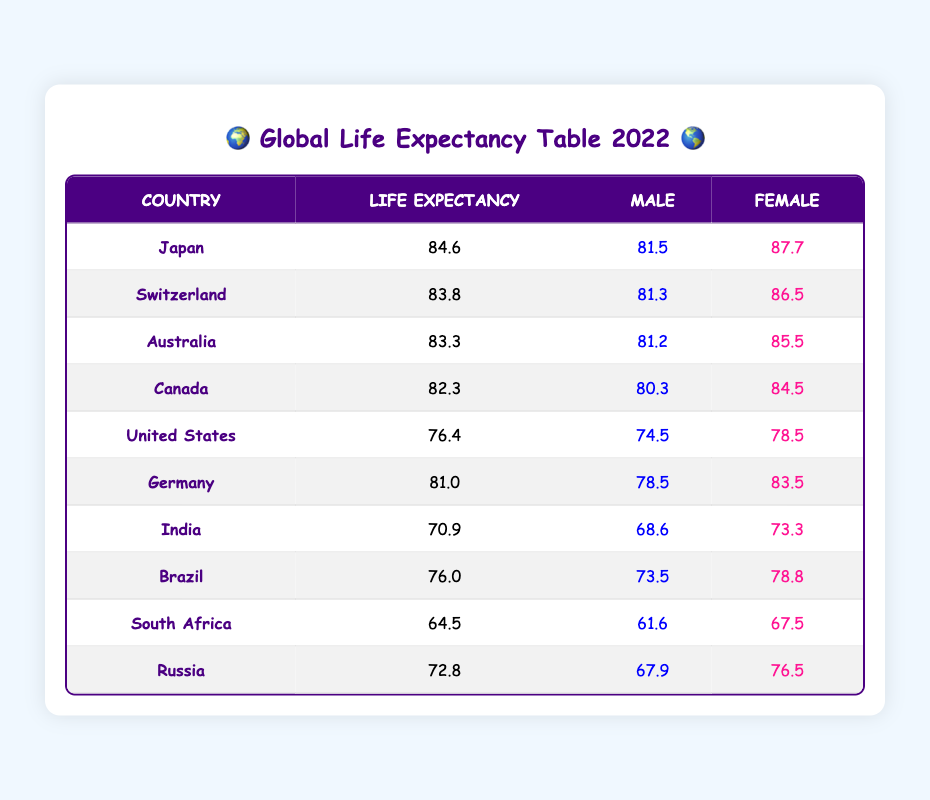What is the life expectancy of Japan? The life expectancy of Japan is directly listed in the table under the life expectancy column for Japan, which shows 84.6 years.
Answer: 84.6 Which country has the highest life expectancy? Looking at the life expectancy column, Japan has the highest value of 84.6, compared to other countries listed.
Answer: Japan What is the life expectancy difference between males and females in Switzerland? For Switzerland, the life expectancy for males is 81.3 and for females is 86.5. The difference is calculated as 86.5 - 81.3 = 5.2 years.
Answer: 5.2 Is the life expectancy of females in India higher than males? The life expectancy for females in India is 73.3 and for males is 68.6. Since 73.3 is greater than 68.6, the answer is yes.
Answer: Yes What is the average life expectancy of the listed countries? The life expectancies of the countries are summed: 84.6 + 83.8 + 83.3 + 82.3 + 76.4 + 81.0 + 70.9 + 76.0 + 64.5 + 72.8 =  743.6. Then, divide by 10 (the number of countries) gives an average of 74.36 years.
Answer: 74.36 How many countries have a life expectancy above 80 years? By inspecting each country in the table, Japan (84.6), Switzerland (83.8), Australia (83.3), and Canada (82.3) have life expectancies above 80 years. This results in a total of 4 countries.
Answer: 4 What is the combined life expectancy of males in Germany and Canada? The life expectancies for males are 78.5 (Germany) and 80.3 (Canada). Their total is 78.5 + 80.3 = 158.8 years.
Answer: 158.8 Is Brazil's life expectancy lower than that of the United States? Brazil has a life expectancy of 76.0 years while the United States has 76.4 years. Comparing these values, 76.0 is indeed less than 76.4, making this statement true.
Answer: Yes What gender shows a greater life expectancy in Japan? The life expectancy for females in Japan is 87.7, which is higher than that for males at 81.5. Thus, females have a greater life expectancy.
Answer: Females What is the difference in life expectancy between South Africa and Russia? For South Africa, the life expectancy is 64.5 years and for Russia, it is 72.8 years. Therefore, the difference is calculated as 72.8 - 64.5 = 8.3 years.
Answer: 8.3 